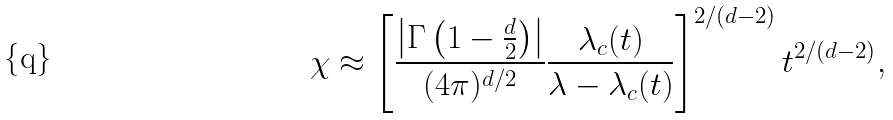Convert formula to latex. <formula><loc_0><loc_0><loc_500><loc_500>\chi \approx \left [ \frac { \left | \Gamma \left ( 1 - \frac { d } { 2 } \right ) \right | } { ( 4 \pi ) ^ { d / 2 } } \frac { \lambda _ { c } ( t ) } { \lambda - \lambda _ { c } ( t ) } \right ] ^ { 2 / ( d - 2 ) } t ^ { 2 / ( d - 2 ) } ,</formula> 